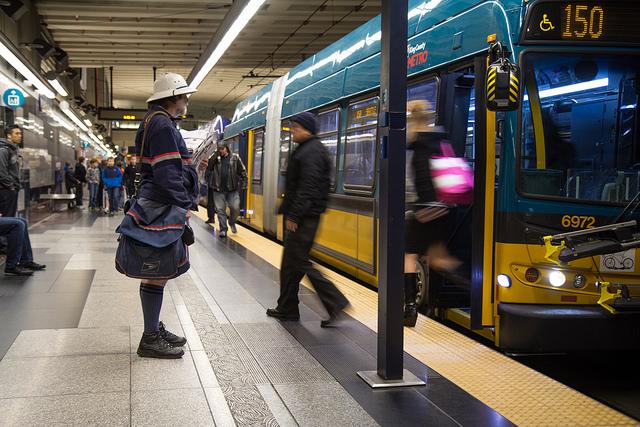Is that a Mailman?
Short answer required. Yes. What is the number on the train?
Answer briefly. 150. Why is the ground surface near the train a different color?
Short answer required. Caution. 